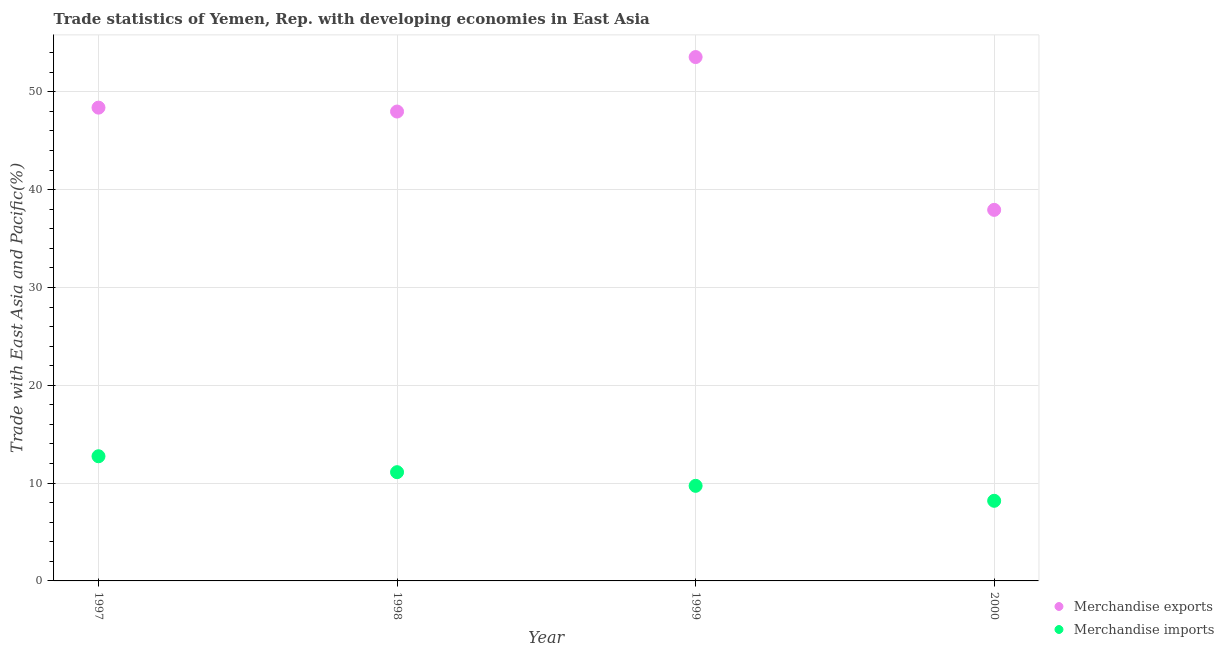Is the number of dotlines equal to the number of legend labels?
Give a very brief answer. Yes. What is the merchandise exports in 2000?
Provide a succinct answer. 37.93. Across all years, what is the maximum merchandise exports?
Your answer should be compact. 53.56. Across all years, what is the minimum merchandise imports?
Your response must be concise. 8.19. In which year was the merchandise imports maximum?
Your response must be concise. 1997. In which year was the merchandise imports minimum?
Keep it short and to the point. 2000. What is the total merchandise exports in the graph?
Provide a succinct answer. 187.86. What is the difference between the merchandise exports in 1998 and that in 2000?
Make the answer very short. 10.05. What is the difference between the merchandise imports in 1997 and the merchandise exports in 2000?
Keep it short and to the point. -25.19. What is the average merchandise exports per year?
Keep it short and to the point. 46.97. In the year 1997, what is the difference between the merchandise exports and merchandise imports?
Your response must be concise. 35.64. In how many years, is the merchandise imports greater than 4 %?
Your response must be concise. 4. What is the ratio of the merchandise imports in 1999 to that in 2000?
Provide a short and direct response. 1.19. What is the difference between the highest and the second highest merchandise imports?
Keep it short and to the point. 1.63. What is the difference between the highest and the lowest merchandise exports?
Your response must be concise. 15.62. Is the sum of the merchandise imports in 1997 and 1999 greater than the maximum merchandise exports across all years?
Offer a terse response. No. Does the merchandise exports monotonically increase over the years?
Offer a terse response. No. Is the merchandise exports strictly greater than the merchandise imports over the years?
Give a very brief answer. Yes. Is the merchandise exports strictly less than the merchandise imports over the years?
Provide a succinct answer. No. How many dotlines are there?
Your answer should be very brief. 2. How many years are there in the graph?
Provide a short and direct response. 4. Are the values on the major ticks of Y-axis written in scientific E-notation?
Provide a short and direct response. No. How many legend labels are there?
Keep it short and to the point. 2. How are the legend labels stacked?
Your answer should be very brief. Vertical. What is the title of the graph?
Offer a very short reply. Trade statistics of Yemen, Rep. with developing economies in East Asia. What is the label or title of the Y-axis?
Your response must be concise. Trade with East Asia and Pacific(%). What is the Trade with East Asia and Pacific(%) of Merchandise exports in 1997?
Your answer should be compact. 48.39. What is the Trade with East Asia and Pacific(%) in Merchandise imports in 1997?
Offer a very short reply. 12.75. What is the Trade with East Asia and Pacific(%) of Merchandise exports in 1998?
Provide a short and direct response. 47.99. What is the Trade with East Asia and Pacific(%) in Merchandise imports in 1998?
Provide a short and direct response. 11.12. What is the Trade with East Asia and Pacific(%) in Merchandise exports in 1999?
Give a very brief answer. 53.56. What is the Trade with East Asia and Pacific(%) in Merchandise imports in 1999?
Provide a succinct answer. 9.72. What is the Trade with East Asia and Pacific(%) of Merchandise exports in 2000?
Make the answer very short. 37.93. What is the Trade with East Asia and Pacific(%) in Merchandise imports in 2000?
Make the answer very short. 8.19. Across all years, what is the maximum Trade with East Asia and Pacific(%) in Merchandise exports?
Your answer should be very brief. 53.56. Across all years, what is the maximum Trade with East Asia and Pacific(%) in Merchandise imports?
Offer a terse response. 12.75. Across all years, what is the minimum Trade with East Asia and Pacific(%) in Merchandise exports?
Provide a short and direct response. 37.93. Across all years, what is the minimum Trade with East Asia and Pacific(%) in Merchandise imports?
Give a very brief answer. 8.19. What is the total Trade with East Asia and Pacific(%) of Merchandise exports in the graph?
Make the answer very short. 187.86. What is the total Trade with East Asia and Pacific(%) of Merchandise imports in the graph?
Your response must be concise. 41.77. What is the difference between the Trade with East Asia and Pacific(%) in Merchandise exports in 1997 and that in 1998?
Offer a terse response. 0.4. What is the difference between the Trade with East Asia and Pacific(%) in Merchandise imports in 1997 and that in 1998?
Provide a short and direct response. 1.63. What is the difference between the Trade with East Asia and Pacific(%) in Merchandise exports in 1997 and that in 1999?
Your answer should be very brief. -5.17. What is the difference between the Trade with East Asia and Pacific(%) of Merchandise imports in 1997 and that in 1999?
Ensure brevity in your answer.  3.02. What is the difference between the Trade with East Asia and Pacific(%) in Merchandise exports in 1997 and that in 2000?
Your answer should be compact. 10.45. What is the difference between the Trade with East Asia and Pacific(%) in Merchandise imports in 1997 and that in 2000?
Your response must be concise. 4.55. What is the difference between the Trade with East Asia and Pacific(%) of Merchandise exports in 1998 and that in 1999?
Provide a succinct answer. -5.57. What is the difference between the Trade with East Asia and Pacific(%) in Merchandise imports in 1998 and that in 1999?
Provide a short and direct response. 1.4. What is the difference between the Trade with East Asia and Pacific(%) in Merchandise exports in 1998 and that in 2000?
Your response must be concise. 10.05. What is the difference between the Trade with East Asia and Pacific(%) in Merchandise imports in 1998 and that in 2000?
Provide a short and direct response. 2.93. What is the difference between the Trade with East Asia and Pacific(%) in Merchandise exports in 1999 and that in 2000?
Your answer should be very brief. 15.62. What is the difference between the Trade with East Asia and Pacific(%) in Merchandise imports in 1999 and that in 2000?
Give a very brief answer. 1.53. What is the difference between the Trade with East Asia and Pacific(%) in Merchandise exports in 1997 and the Trade with East Asia and Pacific(%) in Merchandise imports in 1998?
Make the answer very short. 37.27. What is the difference between the Trade with East Asia and Pacific(%) of Merchandise exports in 1997 and the Trade with East Asia and Pacific(%) of Merchandise imports in 1999?
Offer a very short reply. 38.66. What is the difference between the Trade with East Asia and Pacific(%) of Merchandise exports in 1997 and the Trade with East Asia and Pacific(%) of Merchandise imports in 2000?
Your response must be concise. 40.19. What is the difference between the Trade with East Asia and Pacific(%) in Merchandise exports in 1998 and the Trade with East Asia and Pacific(%) in Merchandise imports in 1999?
Offer a terse response. 38.26. What is the difference between the Trade with East Asia and Pacific(%) of Merchandise exports in 1998 and the Trade with East Asia and Pacific(%) of Merchandise imports in 2000?
Provide a succinct answer. 39.79. What is the difference between the Trade with East Asia and Pacific(%) of Merchandise exports in 1999 and the Trade with East Asia and Pacific(%) of Merchandise imports in 2000?
Your answer should be very brief. 45.36. What is the average Trade with East Asia and Pacific(%) of Merchandise exports per year?
Offer a very short reply. 46.97. What is the average Trade with East Asia and Pacific(%) of Merchandise imports per year?
Give a very brief answer. 10.44. In the year 1997, what is the difference between the Trade with East Asia and Pacific(%) of Merchandise exports and Trade with East Asia and Pacific(%) of Merchandise imports?
Ensure brevity in your answer.  35.64. In the year 1998, what is the difference between the Trade with East Asia and Pacific(%) in Merchandise exports and Trade with East Asia and Pacific(%) in Merchandise imports?
Provide a short and direct response. 36.87. In the year 1999, what is the difference between the Trade with East Asia and Pacific(%) in Merchandise exports and Trade with East Asia and Pacific(%) in Merchandise imports?
Your answer should be very brief. 43.83. In the year 2000, what is the difference between the Trade with East Asia and Pacific(%) in Merchandise exports and Trade with East Asia and Pacific(%) in Merchandise imports?
Your answer should be compact. 29.74. What is the ratio of the Trade with East Asia and Pacific(%) of Merchandise exports in 1997 to that in 1998?
Offer a terse response. 1.01. What is the ratio of the Trade with East Asia and Pacific(%) in Merchandise imports in 1997 to that in 1998?
Offer a very short reply. 1.15. What is the ratio of the Trade with East Asia and Pacific(%) in Merchandise exports in 1997 to that in 1999?
Make the answer very short. 0.9. What is the ratio of the Trade with East Asia and Pacific(%) of Merchandise imports in 1997 to that in 1999?
Ensure brevity in your answer.  1.31. What is the ratio of the Trade with East Asia and Pacific(%) of Merchandise exports in 1997 to that in 2000?
Ensure brevity in your answer.  1.28. What is the ratio of the Trade with East Asia and Pacific(%) of Merchandise imports in 1997 to that in 2000?
Keep it short and to the point. 1.56. What is the ratio of the Trade with East Asia and Pacific(%) of Merchandise exports in 1998 to that in 1999?
Your answer should be very brief. 0.9. What is the ratio of the Trade with East Asia and Pacific(%) of Merchandise imports in 1998 to that in 1999?
Make the answer very short. 1.14. What is the ratio of the Trade with East Asia and Pacific(%) in Merchandise exports in 1998 to that in 2000?
Your response must be concise. 1.26. What is the ratio of the Trade with East Asia and Pacific(%) in Merchandise imports in 1998 to that in 2000?
Provide a succinct answer. 1.36. What is the ratio of the Trade with East Asia and Pacific(%) of Merchandise exports in 1999 to that in 2000?
Make the answer very short. 1.41. What is the ratio of the Trade with East Asia and Pacific(%) of Merchandise imports in 1999 to that in 2000?
Your answer should be very brief. 1.19. What is the difference between the highest and the second highest Trade with East Asia and Pacific(%) in Merchandise exports?
Offer a terse response. 5.17. What is the difference between the highest and the second highest Trade with East Asia and Pacific(%) in Merchandise imports?
Your response must be concise. 1.63. What is the difference between the highest and the lowest Trade with East Asia and Pacific(%) of Merchandise exports?
Keep it short and to the point. 15.62. What is the difference between the highest and the lowest Trade with East Asia and Pacific(%) of Merchandise imports?
Make the answer very short. 4.55. 